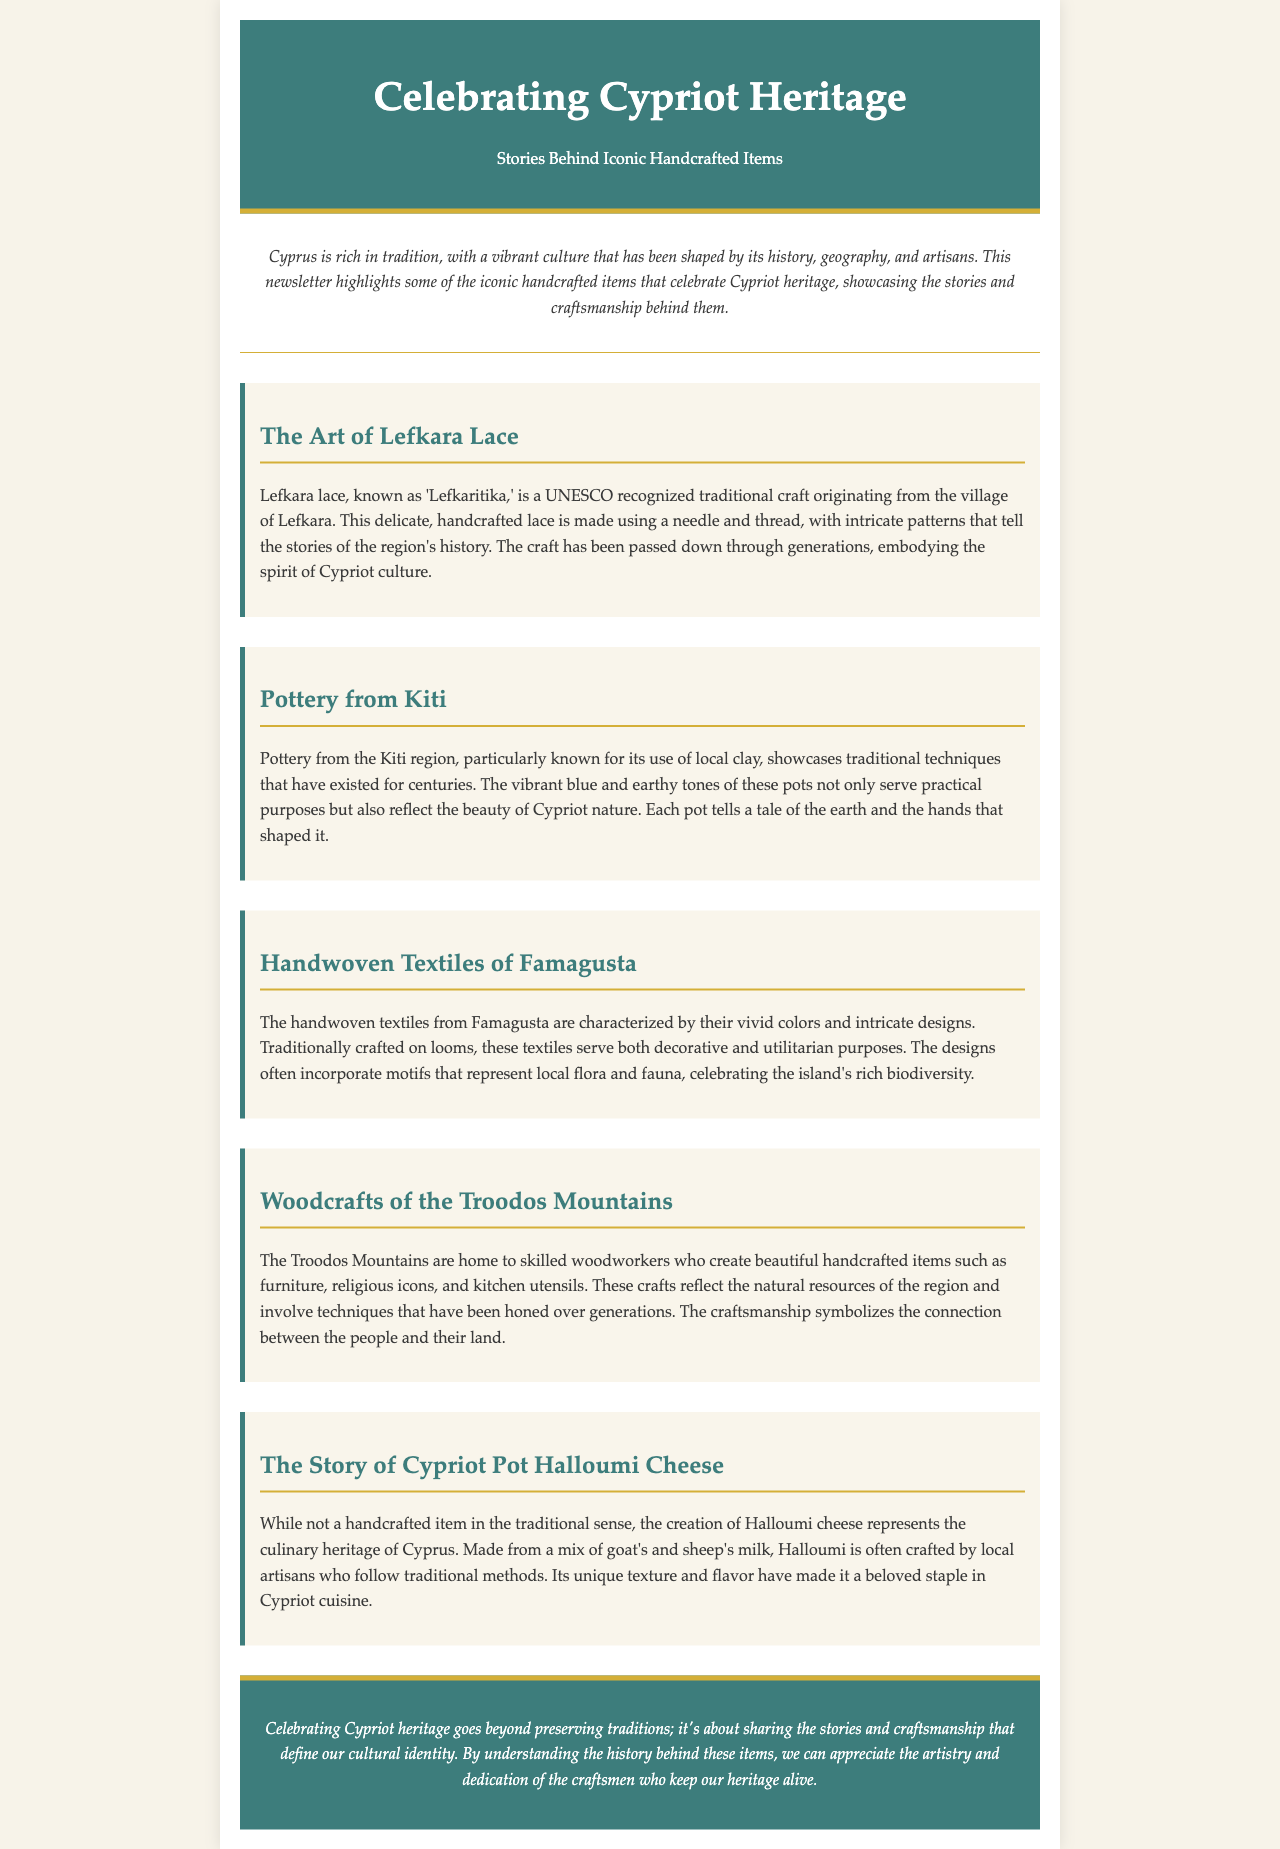What is Lefkara lace also known as? Lefkara lace is referred to as 'Lefkaritika' in the document.
Answer: Lefkaritika Which region's pottery is known for its use of local clay? The document states that pottery from the Kiti region showcases traditional techniques.
Answer: Kiti What are the textiles from Famagusta characterized by? The handwoven textiles from Famagusta are noted for their vivid colors and intricate designs.
Answer: Vivid colors and intricate designs What do woodcrafts from the Troodos Mountains reflect? The woodcrafts reflect the natural resources of the region as explained in the document.
Answer: Natural resources What type of cheese represents the culinary heritage of Cyprus? The document mentions that Halloumi cheese symbolizes Cypriot culinary heritage.
Answer: Halloumi What does celebrating Cypriot heritage involve, according to the conclusion? Celebrating Cypriot heritage is about sharing stories and craftsmanship that define cultural identity.
Answer: Sharing stories and craftsmanship What is the cultural identity of Cyprus described as in the conclusion? The cultural identity of Cyprus is characterized by artistry and dedication, as noted in the document.
Answer: Artistry and dedication How many sections are dedicated to handcrafted items in the newsletter? The document lists five sections dedicated to specific handcrafted items.
Answer: Five 